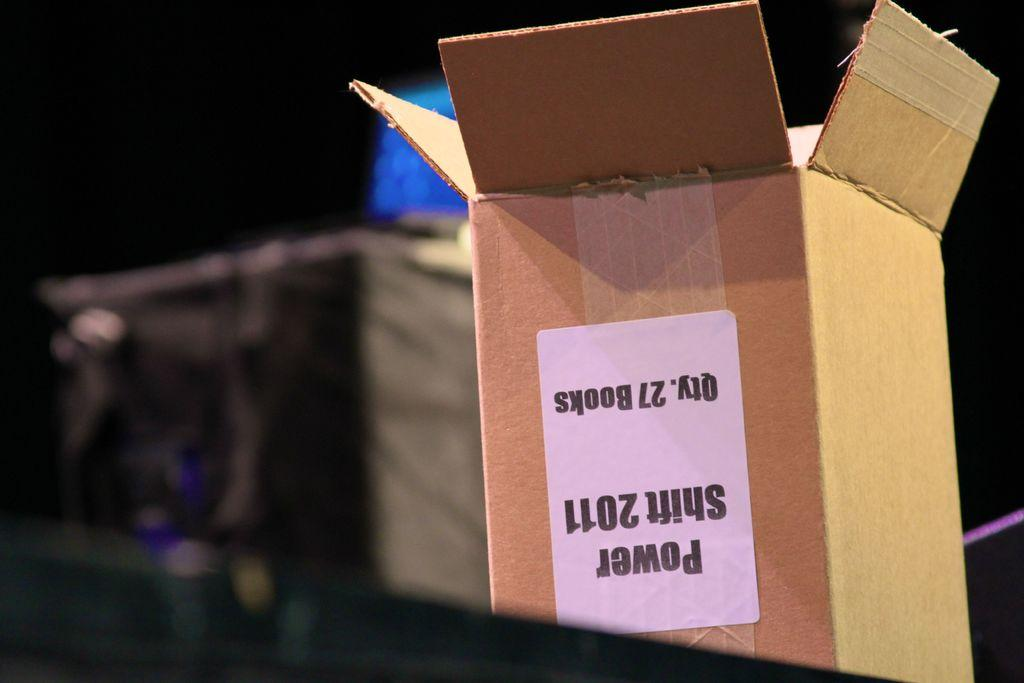<image>
Give a short and clear explanation of the subsequent image. A box marked Power Shift 2011 opened upside down 